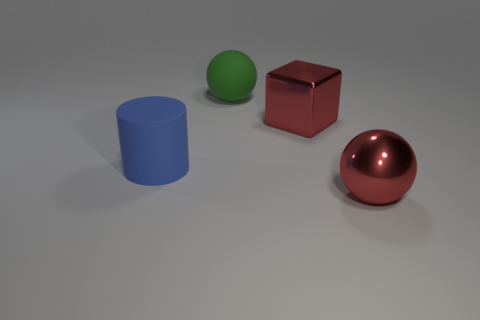Is there any movement or dynamic elements in the scene? The image is a static representation, so there's no actual movement. However, the arrangement of objects and the variance in shapes create a dynamic sense of composition. The metallic sphere, with its reflective surface, could imply the potential for movement due to its association with fluidity and the principle that spherical objects can roll. 